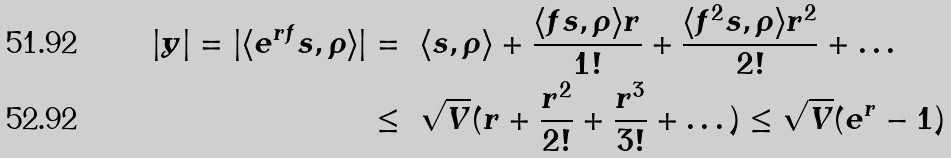<formula> <loc_0><loc_0><loc_500><loc_500>| y | = | \langle e ^ { r f } s , \rho \rangle | & = \ \langle s , \rho \rangle + \frac { \langle f s , \rho \rangle r } { 1 ! } + \frac { \langle f ^ { 2 } s , \rho \rangle r ^ { 2 } } { 2 ! } + \dots \\ & \leq \ \sqrt { V } ( r + \frac { r ^ { 2 } } { 2 ! } + \frac { r ^ { 3 } } { 3 ! } + \dots ) \leq \sqrt { V } ( e ^ { r } - 1 )</formula> 